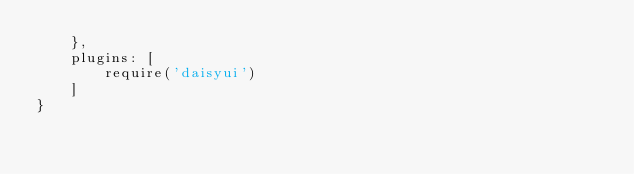Convert code to text. <code><loc_0><loc_0><loc_500><loc_500><_JavaScript_>    },
    plugins: [
        require('daisyui')
    ]
}
</code> 